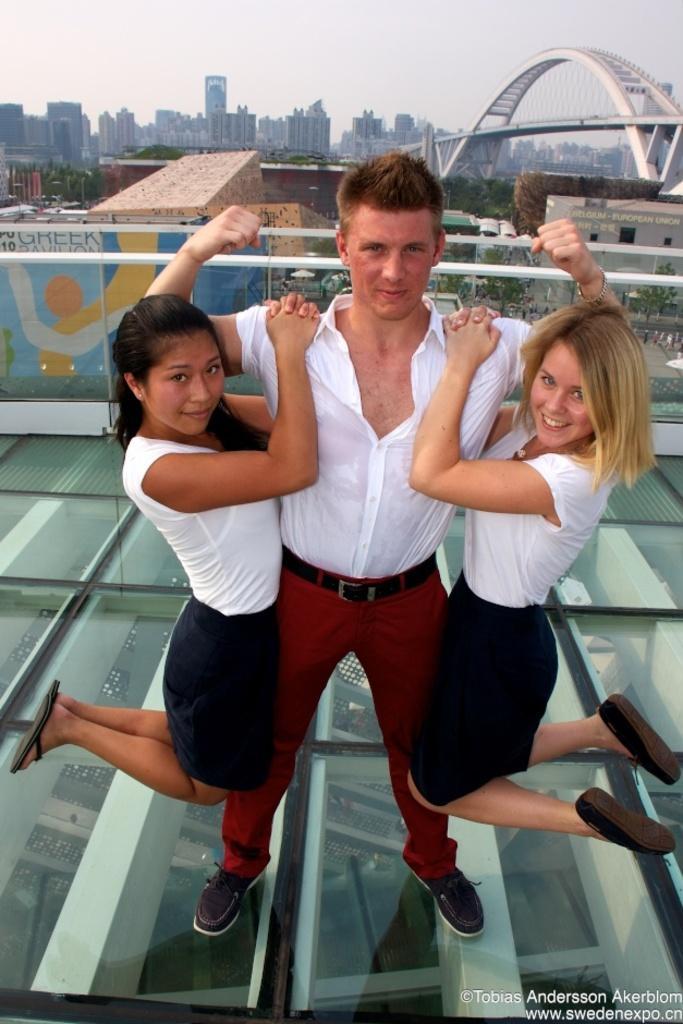Can you describe this image briefly? In this picture there is a boy wearing white color shirt and red trouser holding two girls on the arm, smiling and giving a pose into the camera. Behind there is a metal bridge and some buildings. In the front bottom side there is a glass platform. 